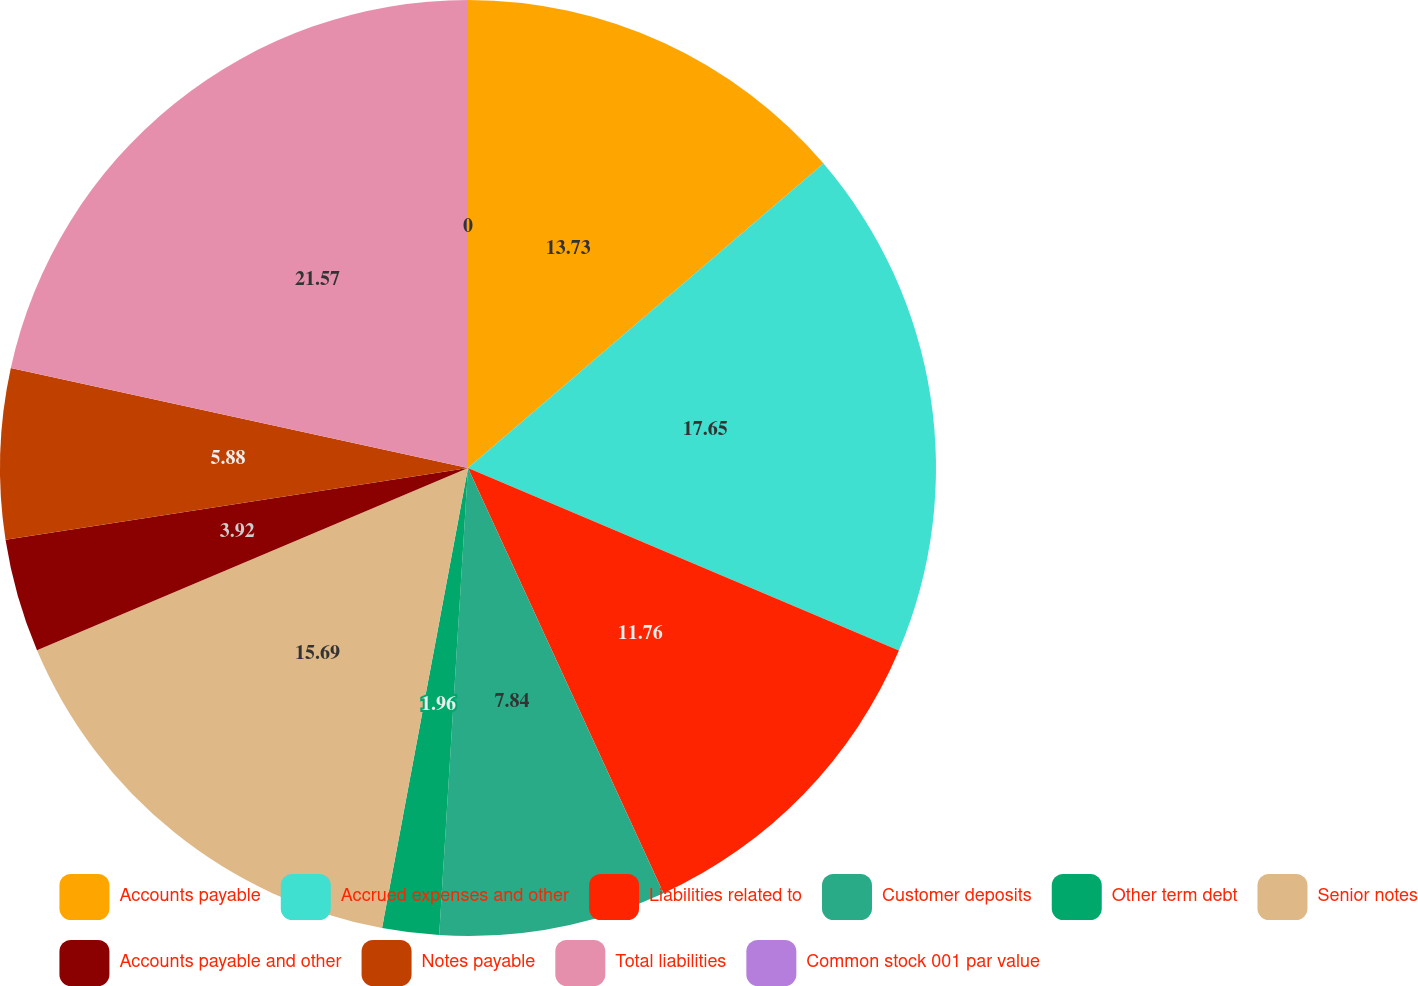Convert chart. <chart><loc_0><loc_0><loc_500><loc_500><pie_chart><fcel>Accounts payable<fcel>Accrued expenses and other<fcel>Liabilities related to<fcel>Customer deposits<fcel>Other term debt<fcel>Senior notes<fcel>Accounts payable and other<fcel>Notes payable<fcel>Total liabilities<fcel>Common stock 001 par value<nl><fcel>13.73%<fcel>17.65%<fcel>11.76%<fcel>7.84%<fcel>1.96%<fcel>15.69%<fcel>3.92%<fcel>5.88%<fcel>21.57%<fcel>0.0%<nl></chart> 